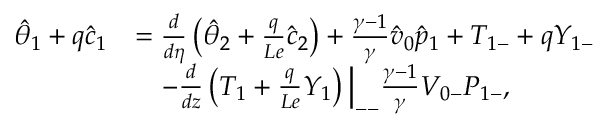Convert formula to latex. <formula><loc_0><loc_0><loc_500><loc_500>\begin{array} { r l } { \hat { \theta } _ { 1 } + q \hat { c } _ { 1 } } & { = \frac { d } { d \eta } \left ( \hat { \theta } _ { 2 } + \frac { q } { L e } \hat { c } _ { 2 } \right ) + \frac { \gamma - 1 } { \gamma } \hat { v } _ { 0 } \hat { p } _ { 1 } + { T } _ { 1 - } + q { Y } _ { 1 - } } \\ & { \quad - \frac { d } { d z } \left ( { T } _ { 1 } + \frac { q } { L e } { Y } _ { 1 } \right ) \Big | _ { - - } \frac { \gamma - 1 } { \gamma } { V } _ { 0 - } { P } _ { 1 - } , } \end{array}</formula> 